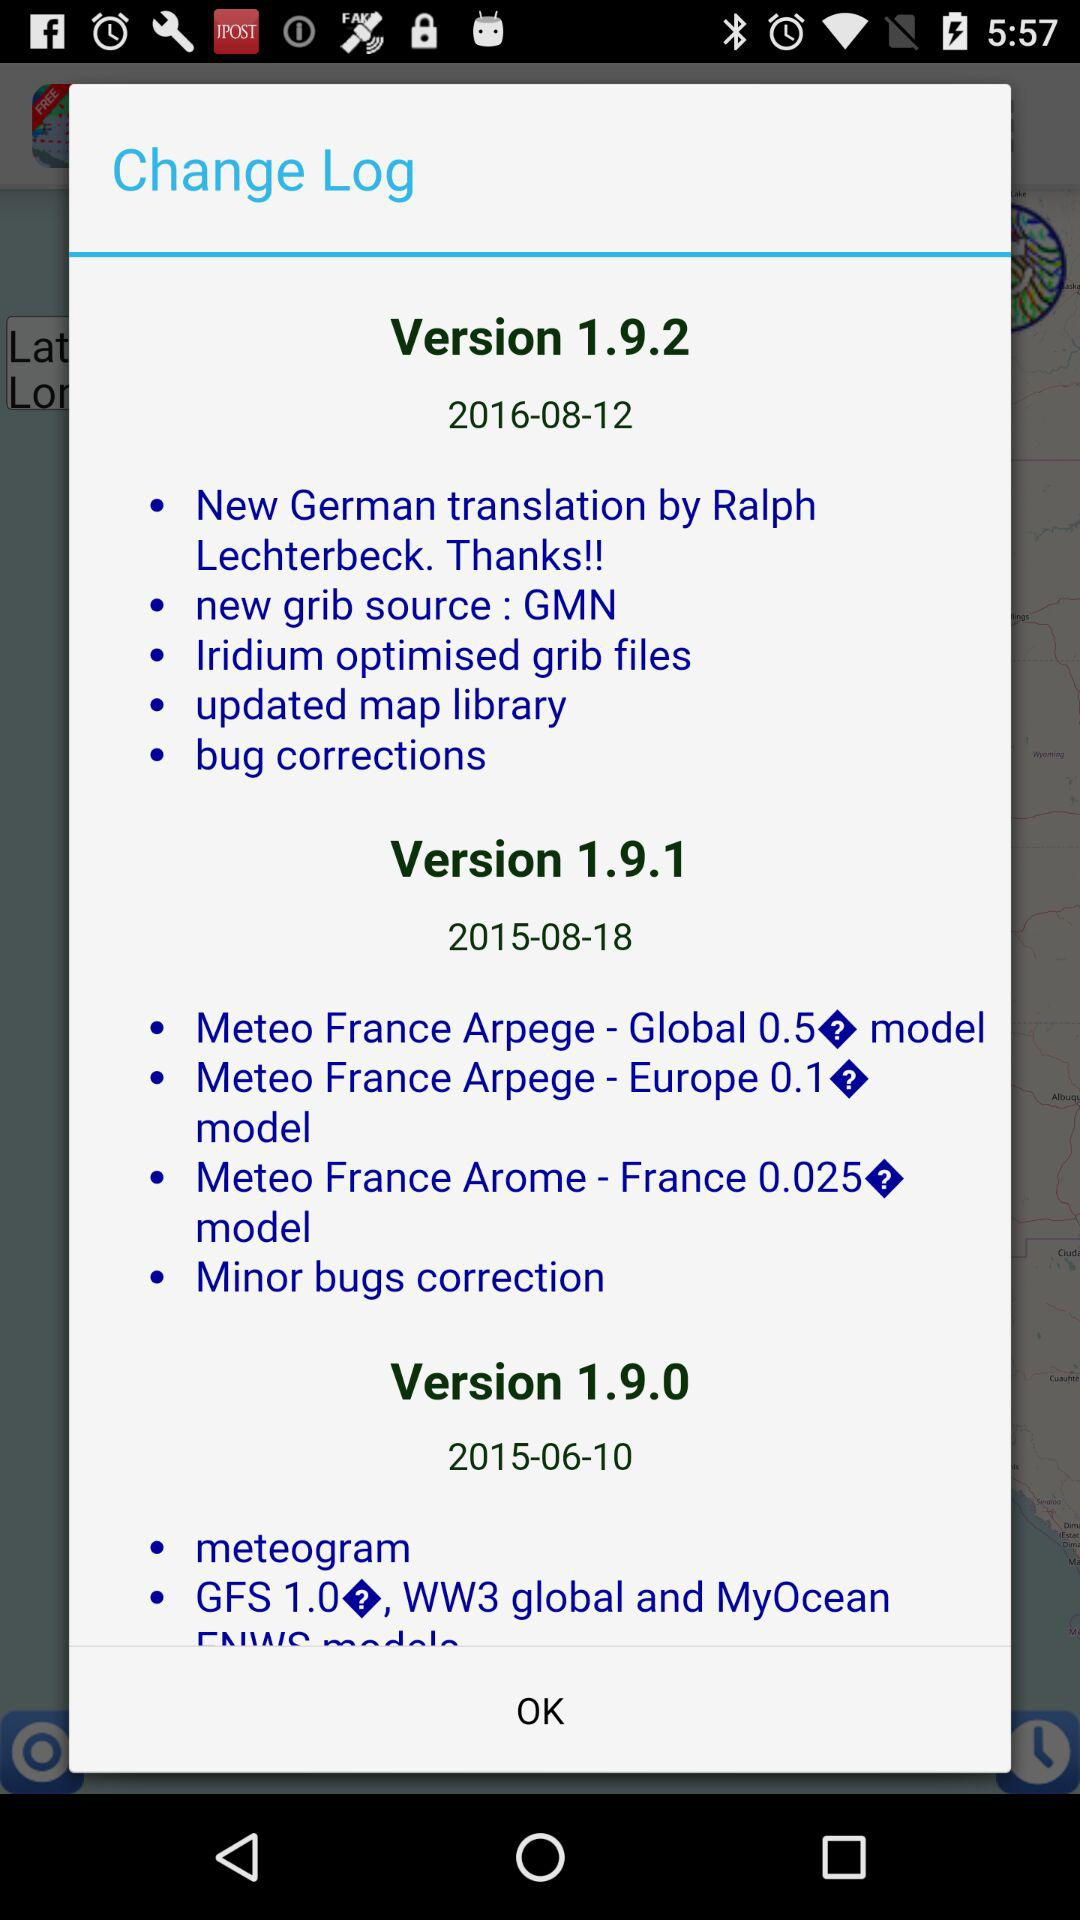Who is the German translator? The German translator is Ralph Lechterbeck. 